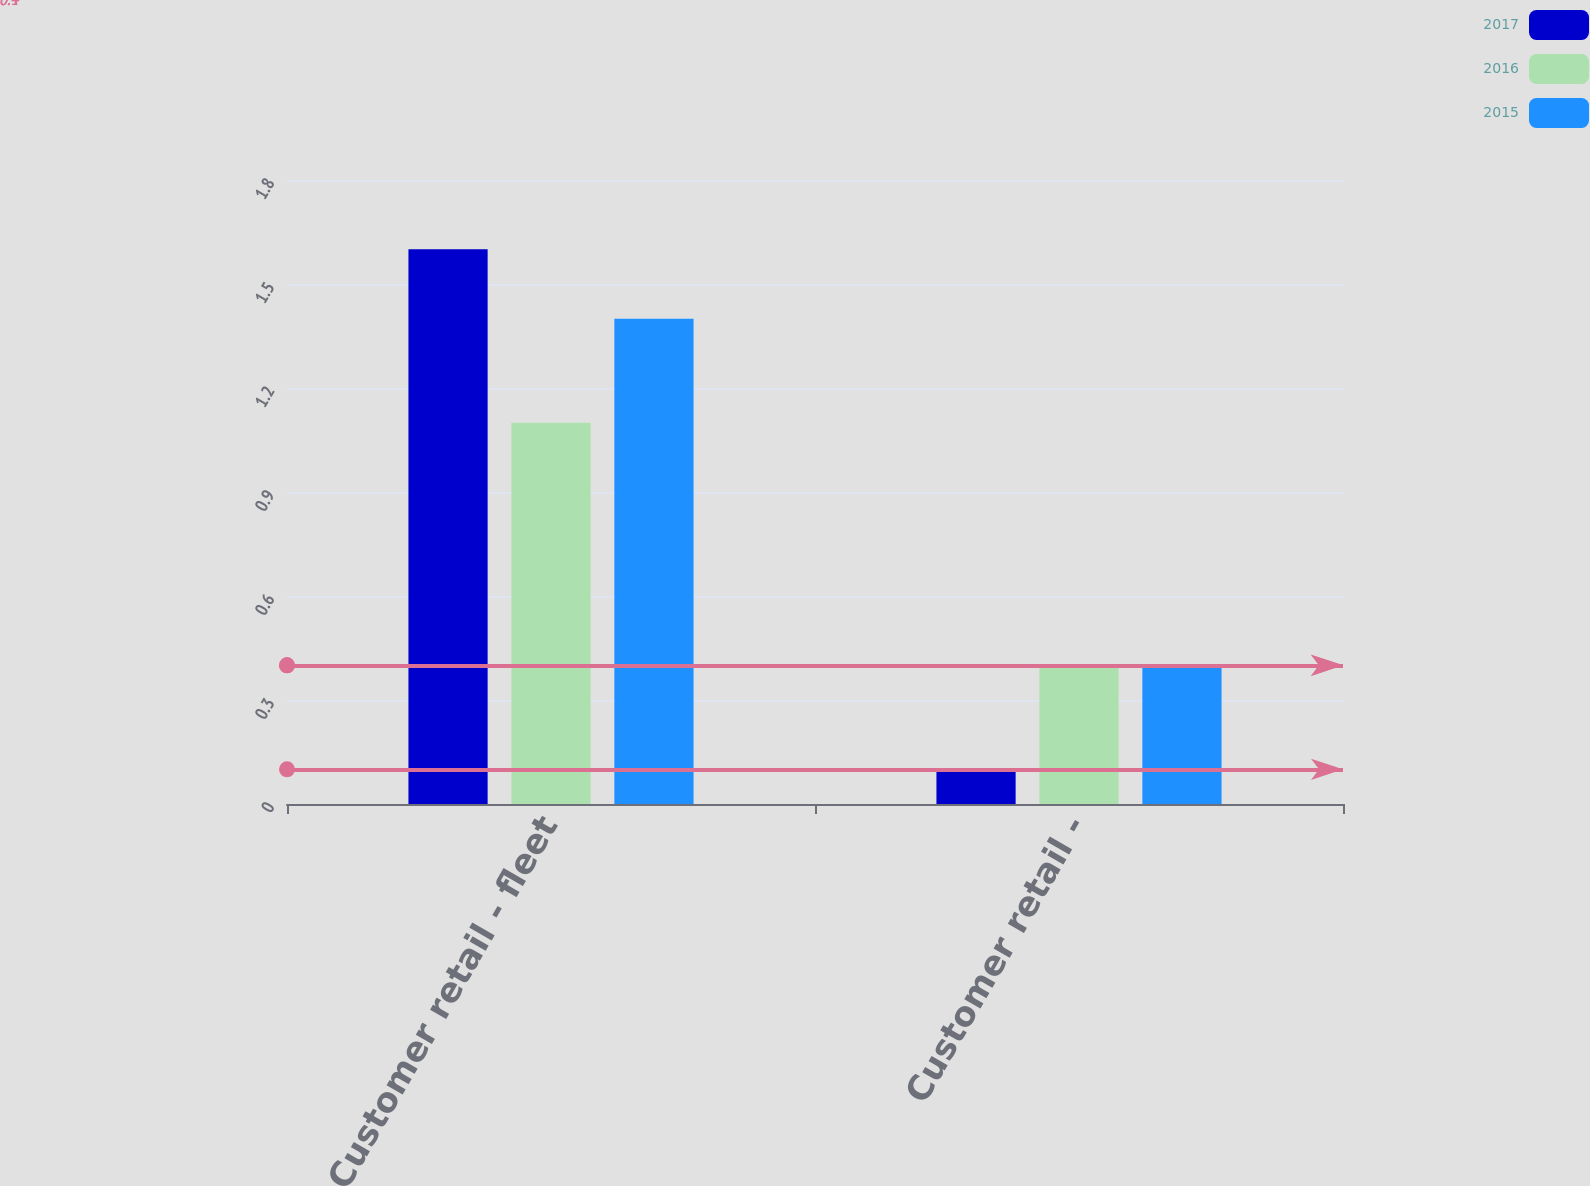Convert chart to OTSL. <chart><loc_0><loc_0><loc_500><loc_500><stacked_bar_chart><ecel><fcel>Customer retail - fleet<fcel>Customer retail -<nl><fcel>2017<fcel>1.6<fcel>0.1<nl><fcel>2016<fcel>1.1<fcel>0.4<nl><fcel>2015<fcel>1.4<fcel>0.4<nl></chart> 